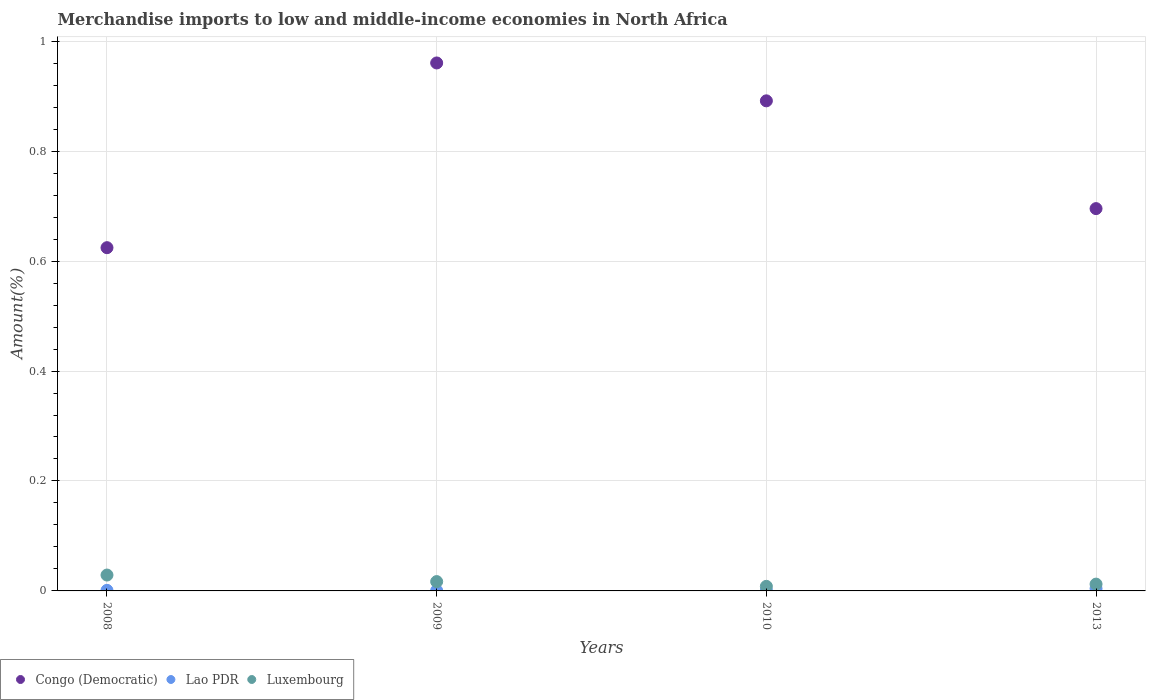Is the number of dotlines equal to the number of legend labels?
Provide a succinct answer. Yes. What is the percentage of amount earned from merchandise imports in Luxembourg in 2013?
Offer a terse response. 0.01. Across all years, what is the maximum percentage of amount earned from merchandise imports in Luxembourg?
Ensure brevity in your answer.  0.03. Across all years, what is the minimum percentage of amount earned from merchandise imports in Luxembourg?
Provide a succinct answer. 0.01. In which year was the percentage of amount earned from merchandise imports in Congo (Democratic) minimum?
Keep it short and to the point. 2008. What is the total percentage of amount earned from merchandise imports in Lao PDR in the graph?
Your response must be concise. 0.01. What is the difference between the percentage of amount earned from merchandise imports in Lao PDR in 2009 and that in 2010?
Offer a terse response. -0. What is the difference between the percentage of amount earned from merchandise imports in Luxembourg in 2010 and the percentage of amount earned from merchandise imports in Congo (Democratic) in 2009?
Offer a terse response. -0.95. What is the average percentage of amount earned from merchandise imports in Congo (Democratic) per year?
Offer a very short reply. 0.79. In the year 2008, what is the difference between the percentage of amount earned from merchandise imports in Luxembourg and percentage of amount earned from merchandise imports in Lao PDR?
Provide a short and direct response. 0.03. What is the ratio of the percentage of amount earned from merchandise imports in Congo (Democratic) in 2008 to that in 2010?
Provide a succinct answer. 0.7. What is the difference between the highest and the second highest percentage of amount earned from merchandise imports in Lao PDR?
Ensure brevity in your answer.  0. What is the difference between the highest and the lowest percentage of amount earned from merchandise imports in Lao PDR?
Your answer should be compact. 0. In how many years, is the percentage of amount earned from merchandise imports in Lao PDR greater than the average percentage of amount earned from merchandise imports in Lao PDR taken over all years?
Your answer should be very brief. 1. Is the sum of the percentage of amount earned from merchandise imports in Congo (Democratic) in 2008 and 2010 greater than the maximum percentage of amount earned from merchandise imports in Lao PDR across all years?
Your answer should be very brief. Yes. Is the percentage of amount earned from merchandise imports in Luxembourg strictly greater than the percentage of amount earned from merchandise imports in Congo (Democratic) over the years?
Provide a short and direct response. No. Is the percentage of amount earned from merchandise imports in Lao PDR strictly less than the percentage of amount earned from merchandise imports in Congo (Democratic) over the years?
Provide a succinct answer. Yes. How many dotlines are there?
Keep it short and to the point. 3. Are the values on the major ticks of Y-axis written in scientific E-notation?
Give a very brief answer. No. Does the graph contain grids?
Your response must be concise. Yes. How are the legend labels stacked?
Your response must be concise. Horizontal. What is the title of the graph?
Provide a succinct answer. Merchandise imports to low and middle-income economies in North Africa. What is the label or title of the Y-axis?
Provide a short and direct response. Amount(%). What is the Amount(%) of Congo (Democratic) in 2008?
Provide a succinct answer. 0.62. What is the Amount(%) in Lao PDR in 2008?
Your answer should be very brief. 0. What is the Amount(%) in Luxembourg in 2008?
Your answer should be compact. 0.03. What is the Amount(%) in Congo (Democratic) in 2009?
Ensure brevity in your answer.  0.96. What is the Amount(%) in Lao PDR in 2009?
Give a very brief answer. 0. What is the Amount(%) of Luxembourg in 2009?
Your answer should be compact. 0.02. What is the Amount(%) of Congo (Democratic) in 2010?
Your answer should be compact. 0.89. What is the Amount(%) in Lao PDR in 2010?
Make the answer very short. 0. What is the Amount(%) of Luxembourg in 2010?
Offer a very short reply. 0.01. What is the Amount(%) in Congo (Democratic) in 2013?
Provide a short and direct response. 0.7. What is the Amount(%) in Lao PDR in 2013?
Provide a short and direct response. 0. What is the Amount(%) of Luxembourg in 2013?
Make the answer very short. 0.01. Across all years, what is the maximum Amount(%) in Congo (Democratic)?
Your response must be concise. 0.96. Across all years, what is the maximum Amount(%) in Lao PDR?
Give a very brief answer. 0. Across all years, what is the maximum Amount(%) of Luxembourg?
Give a very brief answer. 0.03. Across all years, what is the minimum Amount(%) in Congo (Democratic)?
Offer a terse response. 0.62. Across all years, what is the minimum Amount(%) in Lao PDR?
Provide a short and direct response. 0. Across all years, what is the minimum Amount(%) of Luxembourg?
Your answer should be very brief. 0.01. What is the total Amount(%) of Congo (Democratic) in the graph?
Your answer should be very brief. 3.17. What is the total Amount(%) in Lao PDR in the graph?
Give a very brief answer. 0.01. What is the total Amount(%) of Luxembourg in the graph?
Give a very brief answer. 0.07. What is the difference between the Amount(%) in Congo (Democratic) in 2008 and that in 2009?
Your response must be concise. -0.34. What is the difference between the Amount(%) of Luxembourg in 2008 and that in 2009?
Offer a terse response. 0.01. What is the difference between the Amount(%) of Congo (Democratic) in 2008 and that in 2010?
Offer a very short reply. -0.27. What is the difference between the Amount(%) of Luxembourg in 2008 and that in 2010?
Your answer should be very brief. 0.02. What is the difference between the Amount(%) in Congo (Democratic) in 2008 and that in 2013?
Offer a very short reply. -0.07. What is the difference between the Amount(%) in Lao PDR in 2008 and that in 2013?
Give a very brief answer. -0. What is the difference between the Amount(%) in Luxembourg in 2008 and that in 2013?
Your response must be concise. 0.02. What is the difference between the Amount(%) in Congo (Democratic) in 2009 and that in 2010?
Offer a terse response. 0.07. What is the difference between the Amount(%) of Lao PDR in 2009 and that in 2010?
Your response must be concise. -0. What is the difference between the Amount(%) in Luxembourg in 2009 and that in 2010?
Your answer should be very brief. 0.01. What is the difference between the Amount(%) in Congo (Democratic) in 2009 and that in 2013?
Provide a succinct answer. 0.27. What is the difference between the Amount(%) in Lao PDR in 2009 and that in 2013?
Offer a very short reply. -0. What is the difference between the Amount(%) of Luxembourg in 2009 and that in 2013?
Provide a succinct answer. 0. What is the difference between the Amount(%) of Congo (Democratic) in 2010 and that in 2013?
Your answer should be compact. 0.2. What is the difference between the Amount(%) in Lao PDR in 2010 and that in 2013?
Provide a short and direct response. -0. What is the difference between the Amount(%) of Luxembourg in 2010 and that in 2013?
Provide a short and direct response. -0. What is the difference between the Amount(%) in Congo (Democratic) in 2008 and the Amount(%) in Lao PDR in 2009?
Keep it short and to the point. 0.62. What is the difference between the Amount(%) in Congo (Democratic) in 2008 and the Amount(%) in Luxembourg in 2009?
Provide a short and direct response. 0.61. What is the difference between the Amount(%) in Lao PDR in 2008 and the Amount(%) in Luxembourg in 2009?
Your answer should be very brief. -0.02. What is the difference between the Amount(%) of Congo (Democratic) in 2008 and the Amount(%) of Lao PDR in 2010?
Make the answer very short. 0.62. What is the difference between the Amount(%) of Congo (Democratic) in 2008 and the Amount(%) of Luxembourg in 2010?
Offer a terse response. 0.62. What is the difference between the Amount(%) in Lao PDR in 2008 and the Amount(%) in Luxembourg in 2010?
Offer a terse response. -0.01. What is the difference between the Amount(%) of Congo (Democratic) in 2008 and the Amount(%) of Lao PDR in 2013?
Offer a terse response. 0.62. What is the difference between the Amount(%) in Congo (Democratic) in 2008 and the Amount(%) in Luxembourg in 2013?
Provide a succinct answer. 0.61. What is the difference between the Amount(%) in Lao PDR in 2008 and the Amount(%) in Luxembourg in 2013?
Give a very brief answer. -0.01. What is the difference between the Amount(%) of Congo (Democratic) in 2009 and the Amount(%) of Lao PDR in 2010?
Provide a short and direct response. 0.96. What is the difference between the Amount(%) in Congo (Democratic) in 2009 and the Amount(%) in Luxembourg in 2010?
Offer a very short reply. 0.95. What is the difference between the Amount(%) of Lao PDR in 2009 and the Amount(%) of Luxembourg in 2010?
Your response must be concise. -0.01. What is the difference between the Amount(%) of Congo (Democratic) in 2009 and the Amount(%) of Lao PDR in 2013?
Offer a terse response. 0.96. What is the difference between the Amount(%) in Congo (Democratic) in 2009 and the Amount(%) in Luxembourg in 2013?
Keep it short and to the point. 0.95. What is the difference between the Amount(%) in Lao PDR in 2009 and the Amount(%) in Luxembourg in 2013?
Offer a terse response. -0.01. What is the difference between the Amount(%) in Congo (Democratic) in 2010 and the Amount(%) in Lao PDR in 2013?
Keep it short and to the point. 0.89. What is the difference between the Amount(%) of Congo (Democratic) in 2010 and the Amount(%) of Luxembourg in 2013?
Make the answer very short. 0.88. What is the difference between the Amount(%) in Lao PDR in 2010 and the Amount(%) in Luxembourg in 2013?
Give a very brief answer. -0.01. What is the average Amount(%) of Congo (Democratic) per year?
Your answer should be very brief. 0.79. What is the average Amount(%) in Lao PDR per year?
Make the answer very short. 0. What is the average Amount(%) in Luxembourg per year?
Make the answer very short. 0.02. In the year 2008, what is the difference between the Amount(%) in Congo (Democratic) and Amount(%) in Lao PDR?
Make the answer very short. 0.62. In the year 2008, what is the difference between the Amount(%) of Congo (Democratic) and Amount(%) of Luxembourg?
Ensure brevity in your answer.  0.6. In the year 2008, what is the difference between the Amount(%) in Lao PDR and Amount(%) in Luxembourg?
Give a very brief answer. -0.03. In the year 2009, what is the difference between the Amount(%) of Congo (Democratic) and Amount(%) of Lao PDR?
Your response must be concise. 0.96. In the year 2009, what is the difference between the Amount(%) in Congo (Democratic) and Amount(%) in Luxembourg?
Your response must be concise. 0.94. In the year 2009, what is the difference between the Amount(%) in Lao PDR and Amount(%) in Luxembourg?
Your response must be concise. -0.02. In the year 2010, what is the difference between the Amount(%) of Congo (Democratic) and Amount(%) of Lao PDR?
Your answer should be compact. 0.89. In the year 2010, what is the difference between the Amount(%) of Congo (Democratic) and Amount(%) of Luxembourg?
Make the answer very short. 0.88. In the year 2010, what is the difference between the Amount(%) in Lao PDR and Amount(%) in Luxembourg?
Your answer should be very brief. -0.01. In the year 2013, what is the difference between the Amount(%) of Congo (Democratic) and Amount(%) of Lao PDR?
Your response must be concise. 0.69. In the year 2013, what is the difference between the Amount(%) in Congo (Democratic) and Amount(%) in Luxembourg?
Make the answer very short. 0.68. In the year 2013, what is the difference between the Amount(%) in Lao PDR and Amount(%) in Luxembourg?
Give a very brief answer. -0.01. What is the ratio of the Amount(%) in Congo (Democratic) in 2008 to that in 2009?
Provide a succinct answer. 0.65. What is the ratio of the Amount(%) in Lao PDR in 2008 to that in 2009?
Keep it short and to the point. 1.7. What is the ratio of the Amount(%) in Luxembourg in 2008 to that in 2009?
Offer a very short reply. 1.7. What is the ratio of the Amount(%) in Congo (Democratic) in 2008 to that in 2010?
Make the answer very short. 0.7. What is the ratio of the Amount(%) in Lao PDR in 2008 to that in 2010?
Your answer should be compact. 1.07. What is the ratio of the Amount(%) of Luxembourg in 2008 to that in 2010?
Give a very brief answer. 3.48. What is the ratio of the Amount(%) in Congo (Democratic) in 2008 to that in 2013?
Ensure brevity in your answer.  0.9. What is the ratio of the Amount(%) in Lao PDR in 2008 to that in 2013?
Keep it short and to the point. 0.24. What is the ratio of the Amount(%) in Luxembourg in 2008 to that in 2013?
Offer a very short reply. 2.33. What is the ratio of the Amount(%) in Congo (Democratic) in 2009 to that in 2010?
Your response must be concise. 1.08. What is the ratio of the Amount(%) in Lao PDR in 2009 to that in 2010?
Give a very brief answer. 0.63. What is the ratio of the Amount(%) of Luxembourg in 2009 to that in 2010?
Offer a very short reply. 2.04. What is the ratio of the Amount(%) of Congo (Democratic) in 2009 to that in 2013?
Keep it short and to the point. 1.38. What is the ratio of the Amount(%) in Lao PDR in 2009 to that in 2013?
Make the answer very short. 0.14. What is the ratio of the Amount(%) of Luxembourg in 2009 to that in 2013?
Your answer should be compact. 1.37. What is the ratio of the Amount(%) of Congo (Democratic) in 2010 to that in 2013?
Provide a succinct answer. 1.28. What is the ratio of the Amount(%) in Lao PDR in 2010 to that in 2013?
Provide a short and direct response. 0.22. What is the ratio of the Amount(%) in Luxembourg in 2010 to that in 2013?
Make the answer very short. 0.67. What is the difference between the highest and the second highest Amount(%) in Congo (Democratic)?
Ensure brevity in your answer.  0.07. What is the difference between the highest and the second highest Amount(%) of Lao PDR?
Offer a terse response. 0. What is the difference between the highest and the second highest Amount(%) in Luxembourg?
Your answer should be compact. 0.01. What is the difference between the highest and the lowest Amount(%) of Congo (Democratic)?
Make the answer very short. 0.34. What is the difference between the highest and the lowest Amount(%) of Lao PDR?
Keep it short and to the point. 0. What is the difference between the highest and the lowest Amount(%) of Luxembourg?
Provide a short and direct response. 0.02. 